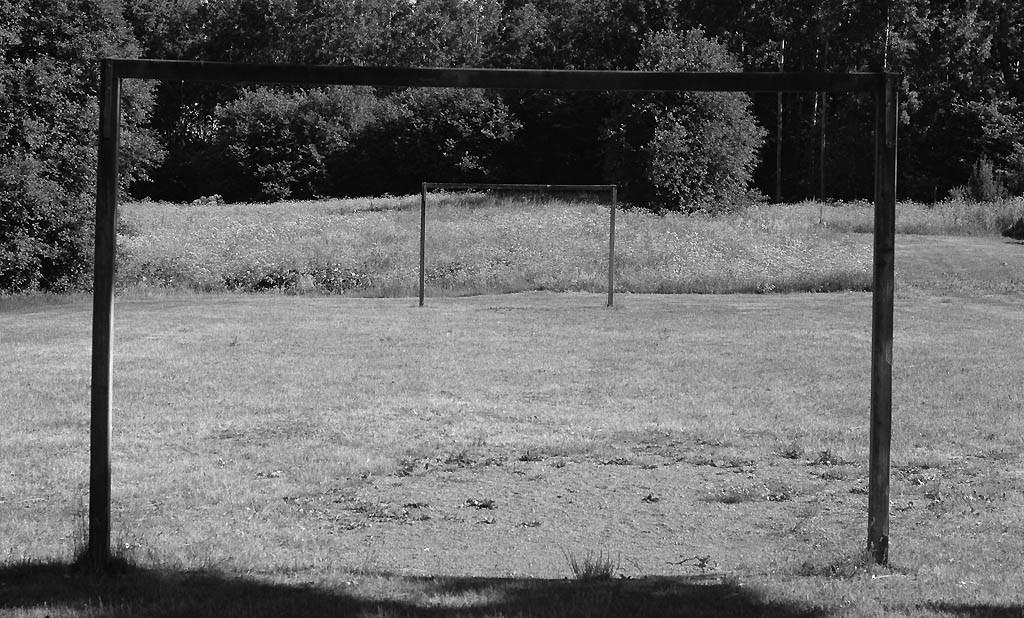Describe this image in one or two sentences. This is a black and white picture, there is a goal post in the front and in the back on the grassland, over the background there are trees. 